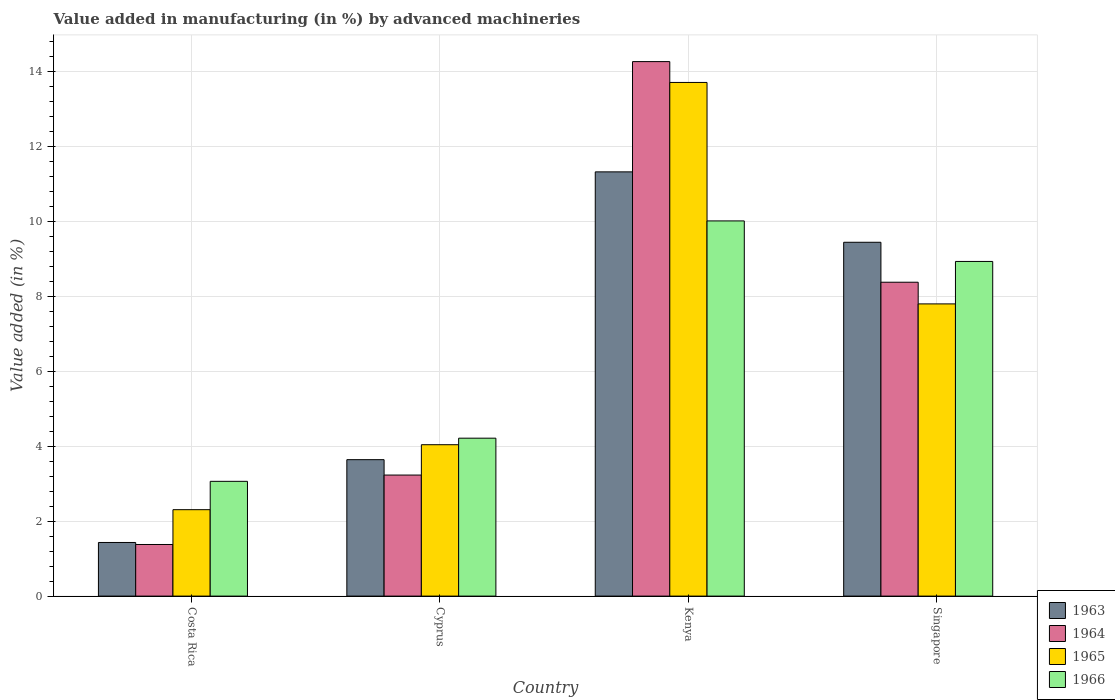How many different coloured bars are there?
Provide a succinct answer. 4. Are the number of bars on each tick of the X-axis equal?
Your answer should be compact. Yes. How many bars are there on the 3rd tick from the left?
Your answer should be compact. 4. What is the label of the 4th group of bars from the left?
Your response must be concise. Singapore. What is the percentage of value added in manufacturing by advanced machineries in 1966 in Cyprus?
Make the answer very short. 4.22. Across all countries, what is the maximum percentage of value added in manufacturing by advanced machineries in 1963?
Your answer should be very brief. 11.32. Across all countries, what is the minimum percentage of value added in manufacturing by advanced machineries in 1964?
Provide a succinct answer. 1.38. In which country was the percentage of value added in manufacturing by advanced machineries in 1965 maximum?
Your answer should be compact. Kenya. In which country was the percentage of value added in manufacturing by advanced machineries in 1964 minimum?
Keep it short and to the point. Costa Rica. What is the total percentage of value added in manufacturing by advanced machineries in 1964 in the graph?
Your answer should be very brief. 27.25. What is the difference between the percentage of value added in manufacturing by advanced machineries in 1965 in Cyprus and that in Singapore?
Your answer should be compact. -3.76. What is the difference between the percentage of value added in manufacturing by advanced machineries in 1966 in Cyprus and the percentage of value added in manufacturing by advanced machineries in 1963 in Costa Rica?
Provide a succinct answer. 2.78. What is the average percentage of value added in manufacturing by advanced machineries in 1964 per country?
Give a very brief answer. 6.81. What is the difference between the percentage of value added in manufacturing by advanced machineries of/in 1963 and percentage of value added in manufacturing by advanced machineries of/in 1964 in Singapore?
Offer a very short reply. 1.07. In how many countries, is the percentage of value added in manufacturing by advanced machineries in 1963 greater than 6 %?
Make the answer very short. 2. What is the ratio of the percentage of value added in manufacturing by advanced machineries in 1963 in Costa Rica to that in Kenya?
Your response must be concise. 0.13. Is the percentage of value added in manufacturing by advanced machineries in 1963 in Costa Rica less than that in Cyprus?
Your answer should be compact. Yes. Is the difference between the percentage of value added in manufacturing by advanced machineries in 1963 in Cyprus and Kenya greater than the difference between the percentage of value added in manufacturing by advanced machineries in 1964 in Cyprus and Kenya?
Keep it short and to the point. Yes. What is the difference between the highest and the second highest percentage of value added in manufacturing by advanced machineries in 1963?
Make the answer very short. -5.8. What is the difference between the highest and the lowest percentage of value added in manufacturing by advanced machineries in 1964?
Make the answer very short. 12.89. Is the sum of the percentage of value added in manufacturing by advanced machineries in 1966 in Costa Rica and Kenya greater than the maximum percentage of value added in manufacturing by advanced machineries in 1963 across all countries?
Ensure brevity in your answer.  Yes. What does the 2nd bar from the left in Cyprus represents?
Your answer should be very brief. 1964. What does the 3rd bar from the right in Cyprus represents?
Your answer should be very brief. 1964. Is it the case that in every country, the sum of the percentage of value added in manufacturing by advanced machineries in 1963 and percentage of value added in manufacturing by advanced machineries in 1965 is greater than the percentage of value added in manufacturing by advanced machineries in 1964?
Make the answer very short. Yes. How many bars are there?
Make the answer very short. 16. Are all the bars in the graph horizontal?
Offer a terse response. No. How many countries are there in the graph?
Make the answer very short. 4. What is the difference between two consecutive major ticks on the Y-axis?
Keep it short and to the point. 2. Are the values on the major ticks of Y-axis written in scientific E-notation?
Make the answer very short. No. Does the graph contain any zero values?
Ensure brevity in your answer.  No. Does the graph contain grids?
Your answer should be very brief. Yes. Where does the legend appear in the graph?
Provide a short and direct response. Bottom right. How many legend labels are there?
Your answer should be very brief. 4. What is the title of the graph?
Offer a very short reply. Value added in manufacturing (in %) by advanced machineries. What is the label or title of the X-axis?
Give a very brief answer. Country. What is the label or title of the Y-axis?
Give a very brief answer. Value added (in %). What is the Value added (in %) in 1963 in Costa Rica?
Provide a short and direct response. 1.43. What is the Value added (in %) in 1964 in Costa Rica?
Give a very brief answer. 1.38. What is the Value added (in %) of 1965 in Costa Rica?
Give a very brief answer. 2.31. What is the Value added (in %) of 1966 in Costa Rica?
Make the answer very short. 3.06. What is the Value added (in %) in 1963 in Cyprus?
Provide a short and direct response. 3.64. What is the Value added (in %) in 1964 in Cyprus?
Your response must be concise. 3.23. What is the Value added (in %) in 1965 in Cyprus?
Make the answer very short. 4.04. What is the Value added (in %) in 1966 in Cyprus?
Provide a short and direct response. 4.22. What is the Value added (in %) of 1963 in Kenya?
Your answer should be very brief. 11.32. What is the Value added (in %) of 1964 in Kenya?
Your answer should be compact. 14.27. What is the Value added (in %) of 1965 in Kenya?
Provide a short and direct response. 13.71. What is the Value added (in %) of 1966 in Kenya?
Your answer should be compact. 10.01. What is the Value added (in %) in 1963 in Singapore?
Keep it short and to the point. 9.44. What is the Value added (in %) in 1964 in Singapore?
Provide a short and direct response. 8.38. What is the Value added (in %) in 1965 in Singapore?
Offer a terse response. 7.8. What is the Value added (in %) of 1966 in Singapore?
Your answer should be compact. 8.93. Across all countries, what is the maximum Value added (in %) in 1963?
Offer a very short reply. 11.32. Across all countries, what is the maximum Value added (in %) of 1964?
Your response must be concise. 14.27. Across all countries, what is the maximum Value added (in %) in 1965?
Your answer should be very brief. 13.71. Across all countries, what is the maximum Value added (in %) in 1966?
Ensure brevity in your answer.  10.01. Across all countries, what is the minimum Value added (in %) in 1963?
Offer a terse response. 1.43. Across all countries, what is the minimum Value added (in %) of 1964?
Give a very brief answer. 1.38. Across all countries, what is the minimum Value added (in %) of 1965?
Give a very brief answer. 2.31. Across all countries, what is the minimum Value added (in %) in 1966?
Offer a very short reply. 3.06. What is the total Value added (in %) in 1963 in the graph?
Your response must be concise. 25.84. What is the total Value added (in %) in 1964 in the graph?
Give a very brief answer. 27.25. What is the total Value added (in %) of 1965 in the graph?
Keep it short and to the point. 27.86. What is the total Value added (in %) in 1966 in the graph?
Offer a terse response. 26.23. What is the difference between the Value added (in %) of 1963 in Costa Rica and that in Cyprus?
Make the answer very short. -2.21. What is the difference between the Value added (in %) of 1964 in Costa Rica and that in Cyprus?
Keep it short and to the point. -1.85. What is the difference between the Value added (in %) in 1965 in Costa Rica and that in Cyprus?
Offer a very short reply. -1.73. What is the difference between the Value added (in %) of 1966 in Costa Rica and that in Cyprus?
Your answer should be compact. -1.15. What is the difference between the Value added (in %) of 1963 in Costa Rica and that in Kenya?
Provide a short and direct response. -9.89. What is the difference between the Value added (in %) of 1964 in Costa Rica and that in Kenya?
Provide a short and direct response. -12.89. What is the difference between the Value added (in %) of 1965 in Costa Rica and that in Kenya?
Provide a succinct answer. -11.4. What is the difference between the Value added (in %) of 1966 in Costa Rica and that in Kenya?
Give a very brief answer. -6.95. What is the difference between the Value added (in %) in 1963 in Costa Rica and that in Singapore?
Offer a terse response. -8.01. What is the difference between the Value added (in %) in 1964 in Costa Rica and that in Singapore?
Keep it short and to the point. -7. What is the difference between the Value added (in %) in 1965 in Costa Rica and that in Singapore?
Your answer should be compact. -5.49. What is the difference between the Value added (in %) of 1966 in Costa Rica and that in Singapore?
Keep it short and to the point. -5.87. What is the difference between the Value added (in %) of 1963 in Cyprus and that in Kenya?
Give a very brief answer. -7.68. What is the difference between the Value added (in %) in 1964 in Cyprus and that in Kenya?
Keep it short and to the point. -11.04. What is the difference between the Value added (in %) of 1965 in Cyprus and that in Kenya?
Offer a terse response. -9.67. What is the difference between the Value added (in %) of 1966 in Cyprus and that in Kenya?
Offer a very short reply. -5.8. What is the difference between the Value added (in %) of 1963 in Cyprus and that in Singapore?
Offer a terse response. -5.8. What is the difference between the Value added (in %) of 1964 in Cyprus and that in Singapore?
Keep it short and to the point. -5.15. What is the difference between the Value added (in %) of 1965 in Cyprus and that in Singapore?
Offer a terse response. -3.76. What is the difference between the Value added (in %) in 1966 in Cyprus and that in Singapore?
Your response must be concise. -4.72. What is the difference between the Value added (in %) of 1963 in Kenya and that in Singapore?
Offer a very short reply. 1.88. What is the difference between the Value added (in %) of 1964 in Kenya and that in Singapore?
Provide a succinct answer. 5.89. What is the difference between the Value added (in %) in 1965 in Kenya and that in Singapore?
Your response must be concise. 5.91. What is the difference between the Value added (in %) in 1966 in Kenya and that in Singapore?
Give a very brief answer. 1.08. What is the difference between the Value added (in %) of 1963 in Costa Rica and the Value added (in %) of 1964 in Cyprus?
Offer a very short reply. -1.8. What is the difference between the Value added (in %) of 1963 in Costa Rica and the Value added (in %) of 1965 in Cyprus?
Give a very brief answer. -2.61. What is the difference between the Value added (in %) of 1963 in Costa Rica and the Value added (in %) of 1966 in Cyprus?
Provide a succinct answer. -2.78. What is the difference between the Value added (in %) of 1964 in Costa Rica and the Value added (in %) of 1965 in Cyprus?
Your response must be concise. -2.66. What is the difference between the Value added (in %) in 1964 in Costa Rica and the Value added (in %) in 1966 in Cyprus?
Make the answer very short. -2.84. What is the difference between the Value added (in %) of 1965 in Costa Rica and the Value added (in %) of 1966 in Cyprus?
Provide a short and direct response. -1.91. What is the difference between the Value added (in %) in 1963 in Costa Rica and the Value added (in %) in 1964 in Kenya?
Your answer should be very brief. -12.84. What is the difference between the Value added (in %) of 1963 in Costa Rica and the Value added (in %) of 1965 in Kenya?
Your answer should be compact. -12.28. What is the difference between the Value added (in %) of 1963 in Costa Rica and the Value added (in %) of 1966 in Kenya?
Ensure brevity in your answer.  -8.58. What is the difference between the Value added (in %) of 1964 in Costa Rica and the Value added (in %) of 1965 in Kenya?
Provide a succinct answer. -12.33. What is the difference between the Value added (in %) of 1964 in Costa Rica and the Value added (in %) of 1966 in Kenya?
Provide a succinct answer. -8.64. What is the difference between the Value added (in %) in 1965 in Costa Rica and the Value added (in %) in 1966 in Kenya?
Your answer should be compact. -7.71. What is the difference between the Value added (in %) of 1963 in Costa Rica and the Value added (in %) of 1964 in Singapore?
Provide a short and direct response. -6.95. What is the difference between the Value added (in %) of 1963 in Costa Rica and the Value added (in %) of 1965 in Singapore?
Offer a terse response. -6.37. What is the difference between the Value added (in %) in 1963 in Costa Rica and the Value added (in %) in 1966 in Singapore?
Keep it short and to the point. -7.5. What is the difference between the Value added (in %) in 1964 in Costa Rica and the Value added (in %) in 1965 in Singapore?
Offer a very short reply. -6.42. What is the difference between the Value added (in %) in 1964 in Costa Rica and the Value added (in %) in 1966 in Singapore?
Provide a short and direct response. -7.55. What is the difference between the Value added (in %) of 1965 in Costa Rica and the Value added (in %) of 1966 in Singapore?
Offer a very short reply. -6.63. What is the difference between the Value added (in %) in 1963 in Cyprus and the Value added (in %) in 1964 in Kenya?
Your response must be concise. -10.63. What is the difference between the Value added (in %) in 1963 in Cyprus and the Value added (in %) in 1965 in Kenya?
Give a very brief answer. -10.07. What is the difference between the Value added (in %) in 1963 in Cyprus and the Value added (in %) in 1966 in Kenya?
Your response must be concise. -6.37. What is the difference between the Value added (in %) of 1964 in Cyprus and the Value added (in %) of 1965 in Kenya?
Ensure brevity in your answer.  -10.48. What is the difference between the Value added (in %) of 1964 in Cyprus and the Value added (in %) of 1966 in Kenya?
Your answer should be very brief. -6.78. What is the difference between the Value added (in %) of 1965 in Cyprus and the Value added (in %) of 1966 in Kenya?
Offer a terse response. -5.97. What is the difference between the Value added (in %) in 1963 in Cyprus and the Value added (in %) in 1964 in Singapore?
Ensure brevity in your answer.  -4.74. What is the difference between the Value added (in %) in 1963 in Cyprus and the Value added (in %) in 1965 in Singapore?
Your answer should be compact. -4.16. What is the difference between the Value added (in %) of 1963 in Cyprus and the Value added (in %) of 1966 in Singapore?
Your answer should be compact. -5.29. What is the difference between the Value added (in %) of 1964 in Cyprus and the Value added (in %) of 1965 in Singapore?
Your answer should be very brief. -4.57. What is the difference between the Value added (in %) in 1964 in Cyprus and the Value added (in %) in 1966 in Singapore?
Your answer should be very brief. -5.7. What is the difference between the Value added (in %) of 1965 in Cyprus and the Value added (in %) of 1966 in Singapore?
Provide a short and direct response. -4.89. What is the difference between the Value added (in %) in 1963 in Kenya and the Value added (in %) in 1964 in Singapore?
Make the answer very short. 2.95. What is the difference between the Value added (in %) of 1963 in Kenya and the Value added (in %) of 1965 in Singapore?
Keep it short and to the point. 3.52. What is the difference between the Value added (in %) in 1963 in Kenya and the Value added (in %) in 1966 in Singapore?
Your answer should be very brief. 2.39. What is the difference between the Value added (in %) of 1964 in Kenya and the Value added (in %) of 1965 in Singapore?
Your answer should be very brief. 6.47. What is the difference between the Value added (in %) in 1964 in Kenya and the Value added (in %) in 1966 in Singapore?
Your response must be concise. 5.33. What is the difference between the Value added (in %) of 1965 in Kenya and the Value added (in %) of 1966 in Singapore?
Your answer should be very brief. 4.78. What is the average Value added (in %) in 1963 per country?
Your answer should be compact. 6.46. What is the average Value added (in %) of 1964 per country?
Keep it short and to the point. 6.81. What is the average Value added (in %) of 1965 per country?
Provide a succinct answer. 6.96. What is the average Value added (in %) in 1966 per country?
Keep it short and to the point. 6.56. What is the difference between the Value added (in %) in 1963 and Value added (in %) in 1964 in Costa Rica?
Make the answer very short. 0.05. What is the difference between the Value added (in %) of 1963 and Value added (in %) of 1965 in Costa Rica?
Ensure brevity in your answer.  -0.88. What is the difference between the Value added (in %) in 1963 and Value added (in %) in 1966 in Costa Rica?
Make the answer very short. -1.63. What is the difference between the Value added (in %) of 1964 and Value added (in %) of 1965 in Costa Rica?
Provide a succinct answer. -0.93. What is the difference between the Value added (in %) in 1964 and Value added (in %) in 1966 in Costa Rica?
Your response must be concise. -1.69. What is the difference between the Value added (in %) of 1965 and Value added (in %) of 1966 in Costa Rica?
Ensure brevity in your answer.  -0.76. What is the difference between the Value added (in %) of 1963 and Value added (in %) of 1964 in Cyprus?
Ensure brevity in your answer.  0.41. What is the difference between the Value added (in %) in 1963 and Value added (in %) in 1965 in Cyprus?
Give a very brief answer. -0.4. What is the difference between the Value added (in %) of 1963 and Value added (in %) of 1966 in Cyprus?
Give a very brief answer. -0.57. What is the difference between the Value added (in %) in 1964 and Value added (in %) in 1965 in Cyprus?
Keep it short and to the point. -0.81. What is the difference between the Value added (in %) of 1964 and Value added (in %) of 1966 in Cyprus?
Your answer should be very brief. -0.98. What is the difference between the Value added (in %) in 1965 and Value added (in %) in 1966 in Cyprus?
Provide a succinct answer. -0.17. What is the difference between the Value added (in %) in 1963 and Value added (in %) in 1964 in Kenya?
Provide a succinct answer. -2.94. What is the difference between the Value added (in %) in 1963 and Value added (in %) in 1965 in Kenya?
Your answer should be very brief. -2.39. What is the difference between the Value added (in %) in 1963 and Value added (in %) in 1966 in Kenya?
Make the answer very short. 1.31. What is the difference between the Value added (in %) of 1964 and Value added (in %) of 1965 in Kenya?
Your answer should be very brief. 0.56. What is the difference between the Value added (in %) of 1964 and Value added (in %) of 1966 in Kenya?
Your answer should be compact. 4.25. What is the difference between the Value added (in %) in 1965 and Value added (in %) in 1966 in Kenya?
Give a very brief answer. 3.7. What is the difference between the Value added (in %) in 1963 and Value added (in %) in 1964 in Singapore?
Offer a very short reply. 1.07. What is the difference between the Value added (in %) of 1963 and Value added (in %) of 1965 in Singapore?
Make the answer very short. 1.64. What is the difference between the Value added (in %) in 1963 and Value added (in %) in 1966 in Singapore?
Provide a succinct answer. 0.51. What is the difference between the Value added (in %) in 1964 and Value added (in %) in 1965 in Singapore?
Your response must be concise. 0.58. What is the difference between the Value added (in %) of 1964 and Value added (in %) of 1966 in Singapore?
Your answer should be very brief. -0.55. What is the difference between the Value added (in %) of 1965 and Value added (in %) of 1966 in Singapore?
Your answer should be compact. -1.13. What is the ratio of the Value added (in %) of 1963 in Costa Rica to that in Cyprus?
Your response must be concise. 0.39. What is the ratio of the Value added (in %) of 1964 in Costa Rica to that in Cyprus?
Keep it short and to the point. 0.43. What is the ratio of the Value added (in %) in 1965 in Costa Rica to that in Cyprus?
Provide a succinct answer. 0.57. What is the ratio of the Value added (in %) of 1966 in Costa Rica to that in Cyprus?
Give a very brief answer. 0.73. What is the ratio of the Value added (in %) in 1963 in Costa Rica to that in Kenya?
Provide a short and direct response. 0.13. What is the ratio of the Value added (in %) in 1964 in Costa Rica to that in Kenya?
Your answer should be compact. 0.1. What is the ratio of the Value added (in %) of 1965 in Costa Rica to that in Kenya?
Make the answer very short. 0.17. What is the ratio of the Value added (in %) in 1966 in Costa Rica to that in Kenya?
Ensure brevity in your answer.  0.31. What is the ratio of the Value added (in %) of 1963 in Costa Rica to that in Singapore?
Provide a short and direct response. 0.15. What is the ratio of the Value added (in %) of 1964 in Costa Rica to that in Singapore?
Ensure brevity in your answer.  0.16. What is the ratio of the Value added (in %) in 1965 in Costa Rica to that in Singapore?
Give a very brief answer. 0.3. What is the ratio of the Value added (in %) in 1966 in Costa Rica to that in Singapore?
Keep it short and to the point. 0.34. What is the ratio of the Value added (in %) of 1963 in Cyprus to that in Kenya?
Offer a very short reply. 0.32. What is the ratio of the Value added (in %) of 1964 in Cyprus to that in Kenya?
Provide a succinct answer. 0.23. What is the ratio of the Value added (in %) of 1965 in Cyprus to that in Kenya?
Offer a very short reply. 0.29. What is the ratio of the Value added (in %) in 1966 in Cyprus to that in Kenya?
Provide a succinct answer. 0.42. What is the ratio of the Value added (in %) of 1963 in Cyprus to that in Singapore?
Your answer should be compact. 0.39. What is the ratio of the Value added (in %) in 1964 in Cyprus to that in Singapore?
Provide a short and direct response. 0.39. What is the ratio of the Value added (in %) in 1965 in Cyprus to that in Singapore?
Your answer should be very brief. 0.52. What is the ratio of the Value added (in %) in 1966 in Cyprus to that in Singapore?
Provide a succinct answer. 0.47. What is the ratio of the Value added (in %) of 1963 in Kenya to that in Singapore?
Provide a succinct answer. 1.2. What is the ratio of the Value added (in %) in 1964 in Kenya to that in Singapore?
Your answer should be compact. 1.7. What is the ratio of the Value added (in %) in 1965 in Kenya to that in Singapore?
Provide a succinct answer. 1.76. What is the ratio of the Value added (in %) in 1966 in Kenya to that in Singapore?
Your answer should be compact. 1.12. What is the difference between the highest and the second highest Value added (in %) of 1963?
Your response must be concise. 1.88. What is the difference between the highest and the second highest Value added (in %) of 1964?
Make the answer very short. 5.89. What is the difference between the highest and the second highest Value added (in %) of 1965?
Your response must be concise. 5.91. What is the difference between the highest and the second highest Value added (in %) in 1966?
Your answer should be compact. 1.08. What is the difference between the highest and the lowest Value added (in %) of 1963?
Offer a very short reply. 9.89. What is the difference between the highest and the lowest Value added (in %) of 1964?
Your answer should be very brief. 12.89. What is the difference between the highest and the lowest Value added (in %) of 1965?
Make the answer very short. 11.4. What is the difference between the highest and the lowest Value added (in %) of 1966?
Keep it short and to the point. 6.95. 